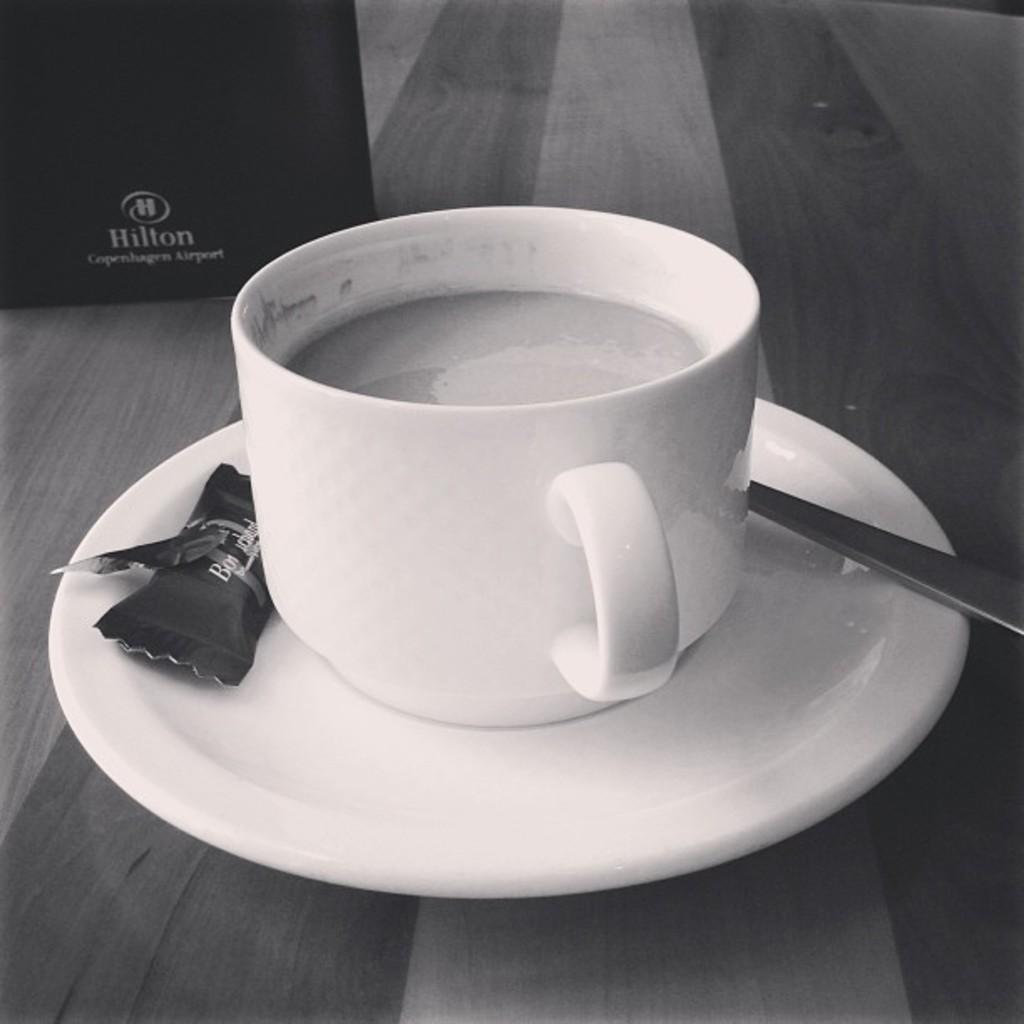How would you summarize this image in a sentence or two? In this picture we can see a cup, spoon and a cover on the saucer, and we can find drink in the cup. 